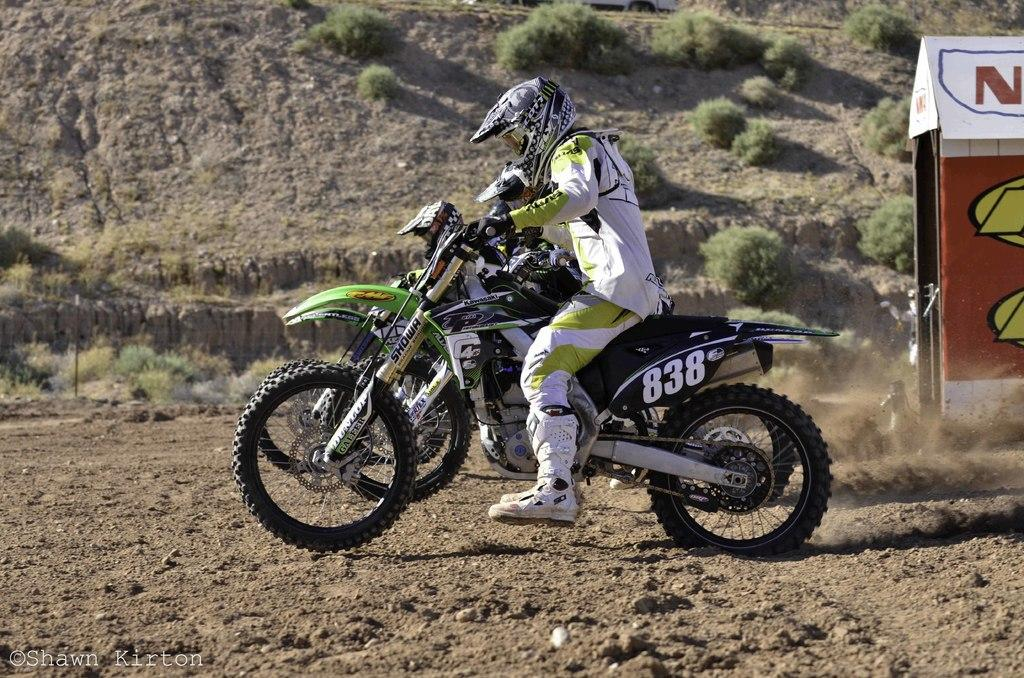What are the people in the image doing? The people in the image are riding motorcycles. What safety precaution are the people taking while riding motorcycles? The people are wearing helmets. What can be seen in the background of the image? There are trees on a hill and a small house in the image. What color crayon is the daughter using to draw the motorcycles in the image? There is no daughter or crayon present in the image. 